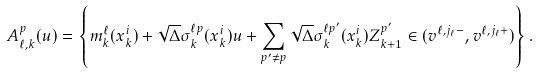Convert formula to latex. <formula><loc_0><loc_0><loc_500><loc_500>A _ { \ell , k } ^ { p } ( u ) = \left \{ m _ { k } ^ { \ell } ( x _ { k } ^ { i } ) + \sqrt { \Delta } \sigma _ { k } ^ { \ell p } ( x _ { k } ^ { i } ) u + \sum _ { p ^ { \prime } \not = p } \sqrt { \Delta } \sigma _ { k } ^ { \ell p ^ { \prime } } ( x _ { k } ^ { i } ) Z _ { k + 1 } ^ { p ^ { \prime } } \in ( v ^ { \ell , j _ { \ell } - } , v ^ { \ell , j _ { \ell } + } ) \right \} .</formula> 